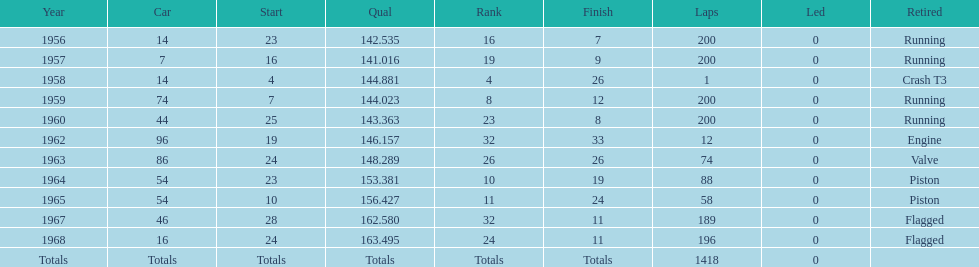In which decade did bob veith cover more indy 500 laps, the 1950s or 1960s? 1960s. 